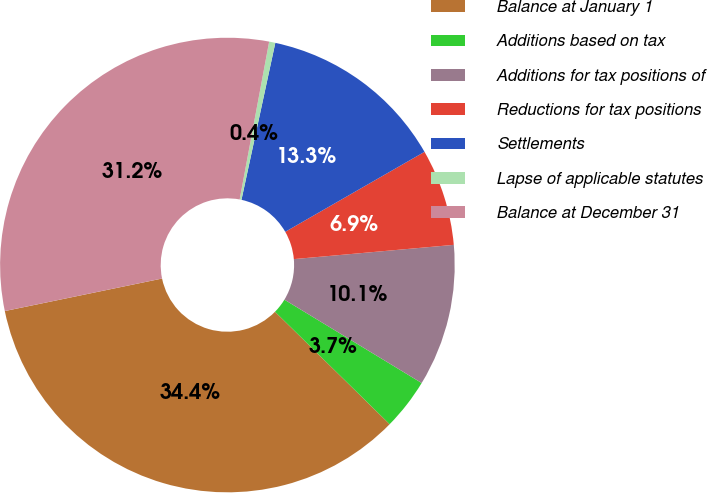<chart> <loc_0><loc_0><loc_500><loc_500><pie_chart><fcel>Balance at January 1<fcel>Additions based on tax<fcel>Additions for tax positions of<fcel>Reductions for tax positions<fcel>Settlements<fcel>Lapse of applicable statutes<fcel>Balance at December 31<nl><fcel>34.4%<fcel>3.66%<fcel>10.1%<fcel>6.88%<fcel>13.32%<fcel>0.44%<fcel>31.18%<nl></chart> 